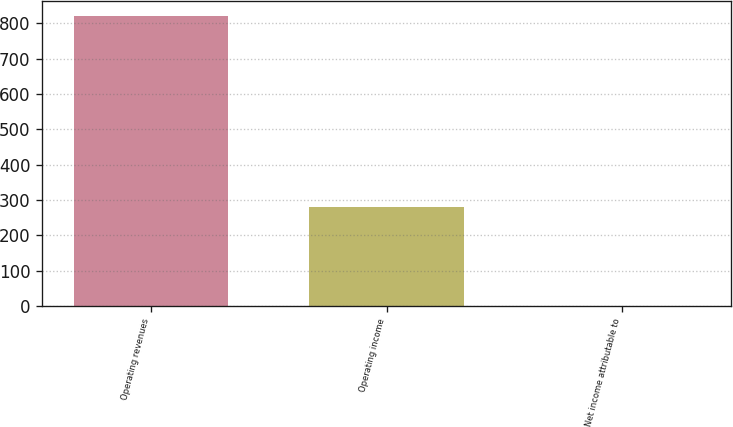<chart> <loc_0><loc_0><loc_500><loc_500><bar_chart><fcel>Operating revenues<fcel>Operating income<fcel>Net income attributable to<nl><fcel>821<fcel>281<fcel>1<nl></chart> 